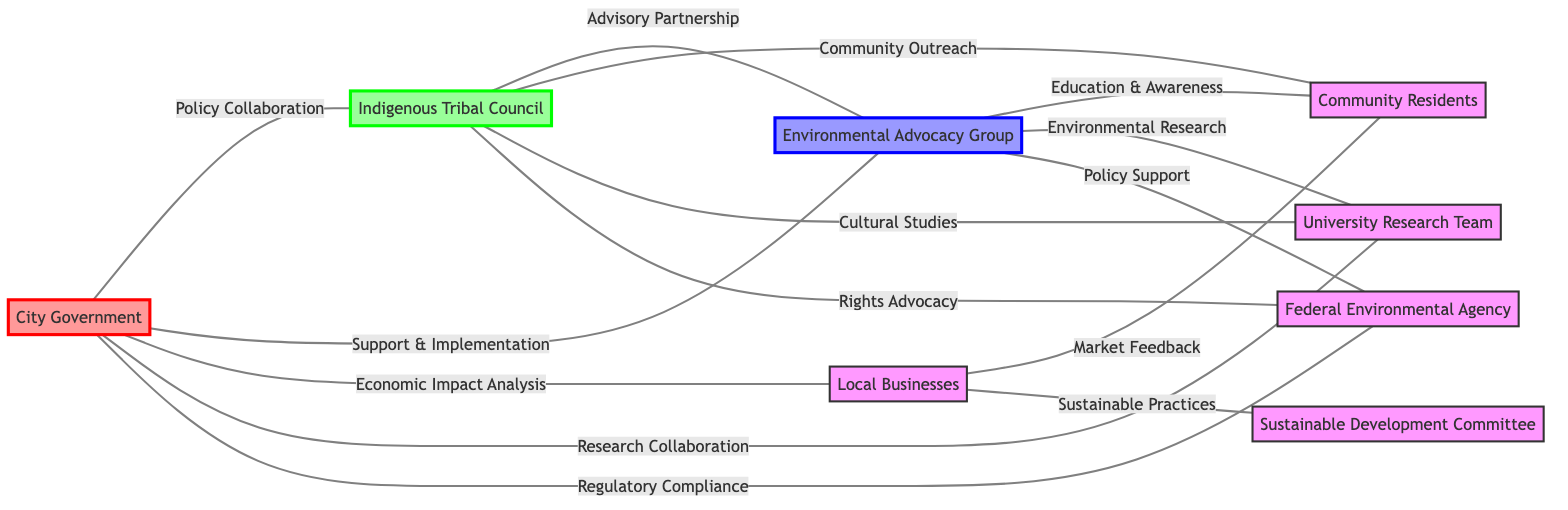What is the total number of nodes in the diagram? The diagram lists 8 distinct entities including the City Government, Indigenous Tribal Council, Environmental Advocacy Group, Local Businesses, Community Residents, Sustainable Development Committee, University Research Team, and Federal Environmental Agency. Each of these counts as a node.
Answer: 8 Who collaborates with the City Government on policy? According to the diagram, the City Government collaborates on policy with the Indigenous Tribal Council and the Environmental Advocacy Group, as indicated by the connections labeled "Policy Collaboration" and "Support & Implementation."
Answer: Indigenous Tribal Council, Environmental Advocacy Group What type of relationship exists between the Indigenous Tribal Council and the Environmental Advocacy Group? The relationship between these two entities is described as an "Advisory Partnership," as represented by the labeled edge connecting them in the diagram.
Answer: Advisory Partnership Which node has the most connections, and how many are there? By examining the edges, the Indigenous Tribal Council connects with the City Government, Environmental Advocacy Group, Community Residents, University Research Team, and Federal Environmental Agency, totaling 5 connections (or edges).
Answer: Indigenous Tribal Council, 5 What is the label of the edge connecting the Environmental Advocacy Group to the Community Residents? The edge connecting these two nodes is labeled "Education & Awareness," indicating the purpose of their connection in promoting community engagement through education initiatives.
Answer: Education & Awareness Which nodes are involved in cultural studies? The diagram indicates that the Indigenous Tribal Council and the University Research Team are connected through the label "Cultural Studies," which highlights their collaboration in this area.
Answer: Indigenous Tribal Council, University Research Team How many edges are there in total within this graph? By counting the directed connections (edges) connecting the various nodes, there are 13 edges that describe the relationships amongst specified entities, which can be tallied from the connections in the diagram.
Answer: 13 What is the relationship between Local Businesses and Community Residents? The local businesses engage with community residents through "Market Feedback," which implies a collaborative effort to understand consumer needs and preferences from the local community.
Answer: Market Feedback Which groups are advocating for rights in conjunction with the Federal Environmental Agency? The Indigenous Tribal Council and the Environmental Advocacy Group both engage in "Rights Advocacy" with the Federal Environmental Agency, indicating their collaboration in advancing indigenous rights and environmental protection.
Answer: Indigenous Tribal Council, Environmental Advocacy Group 